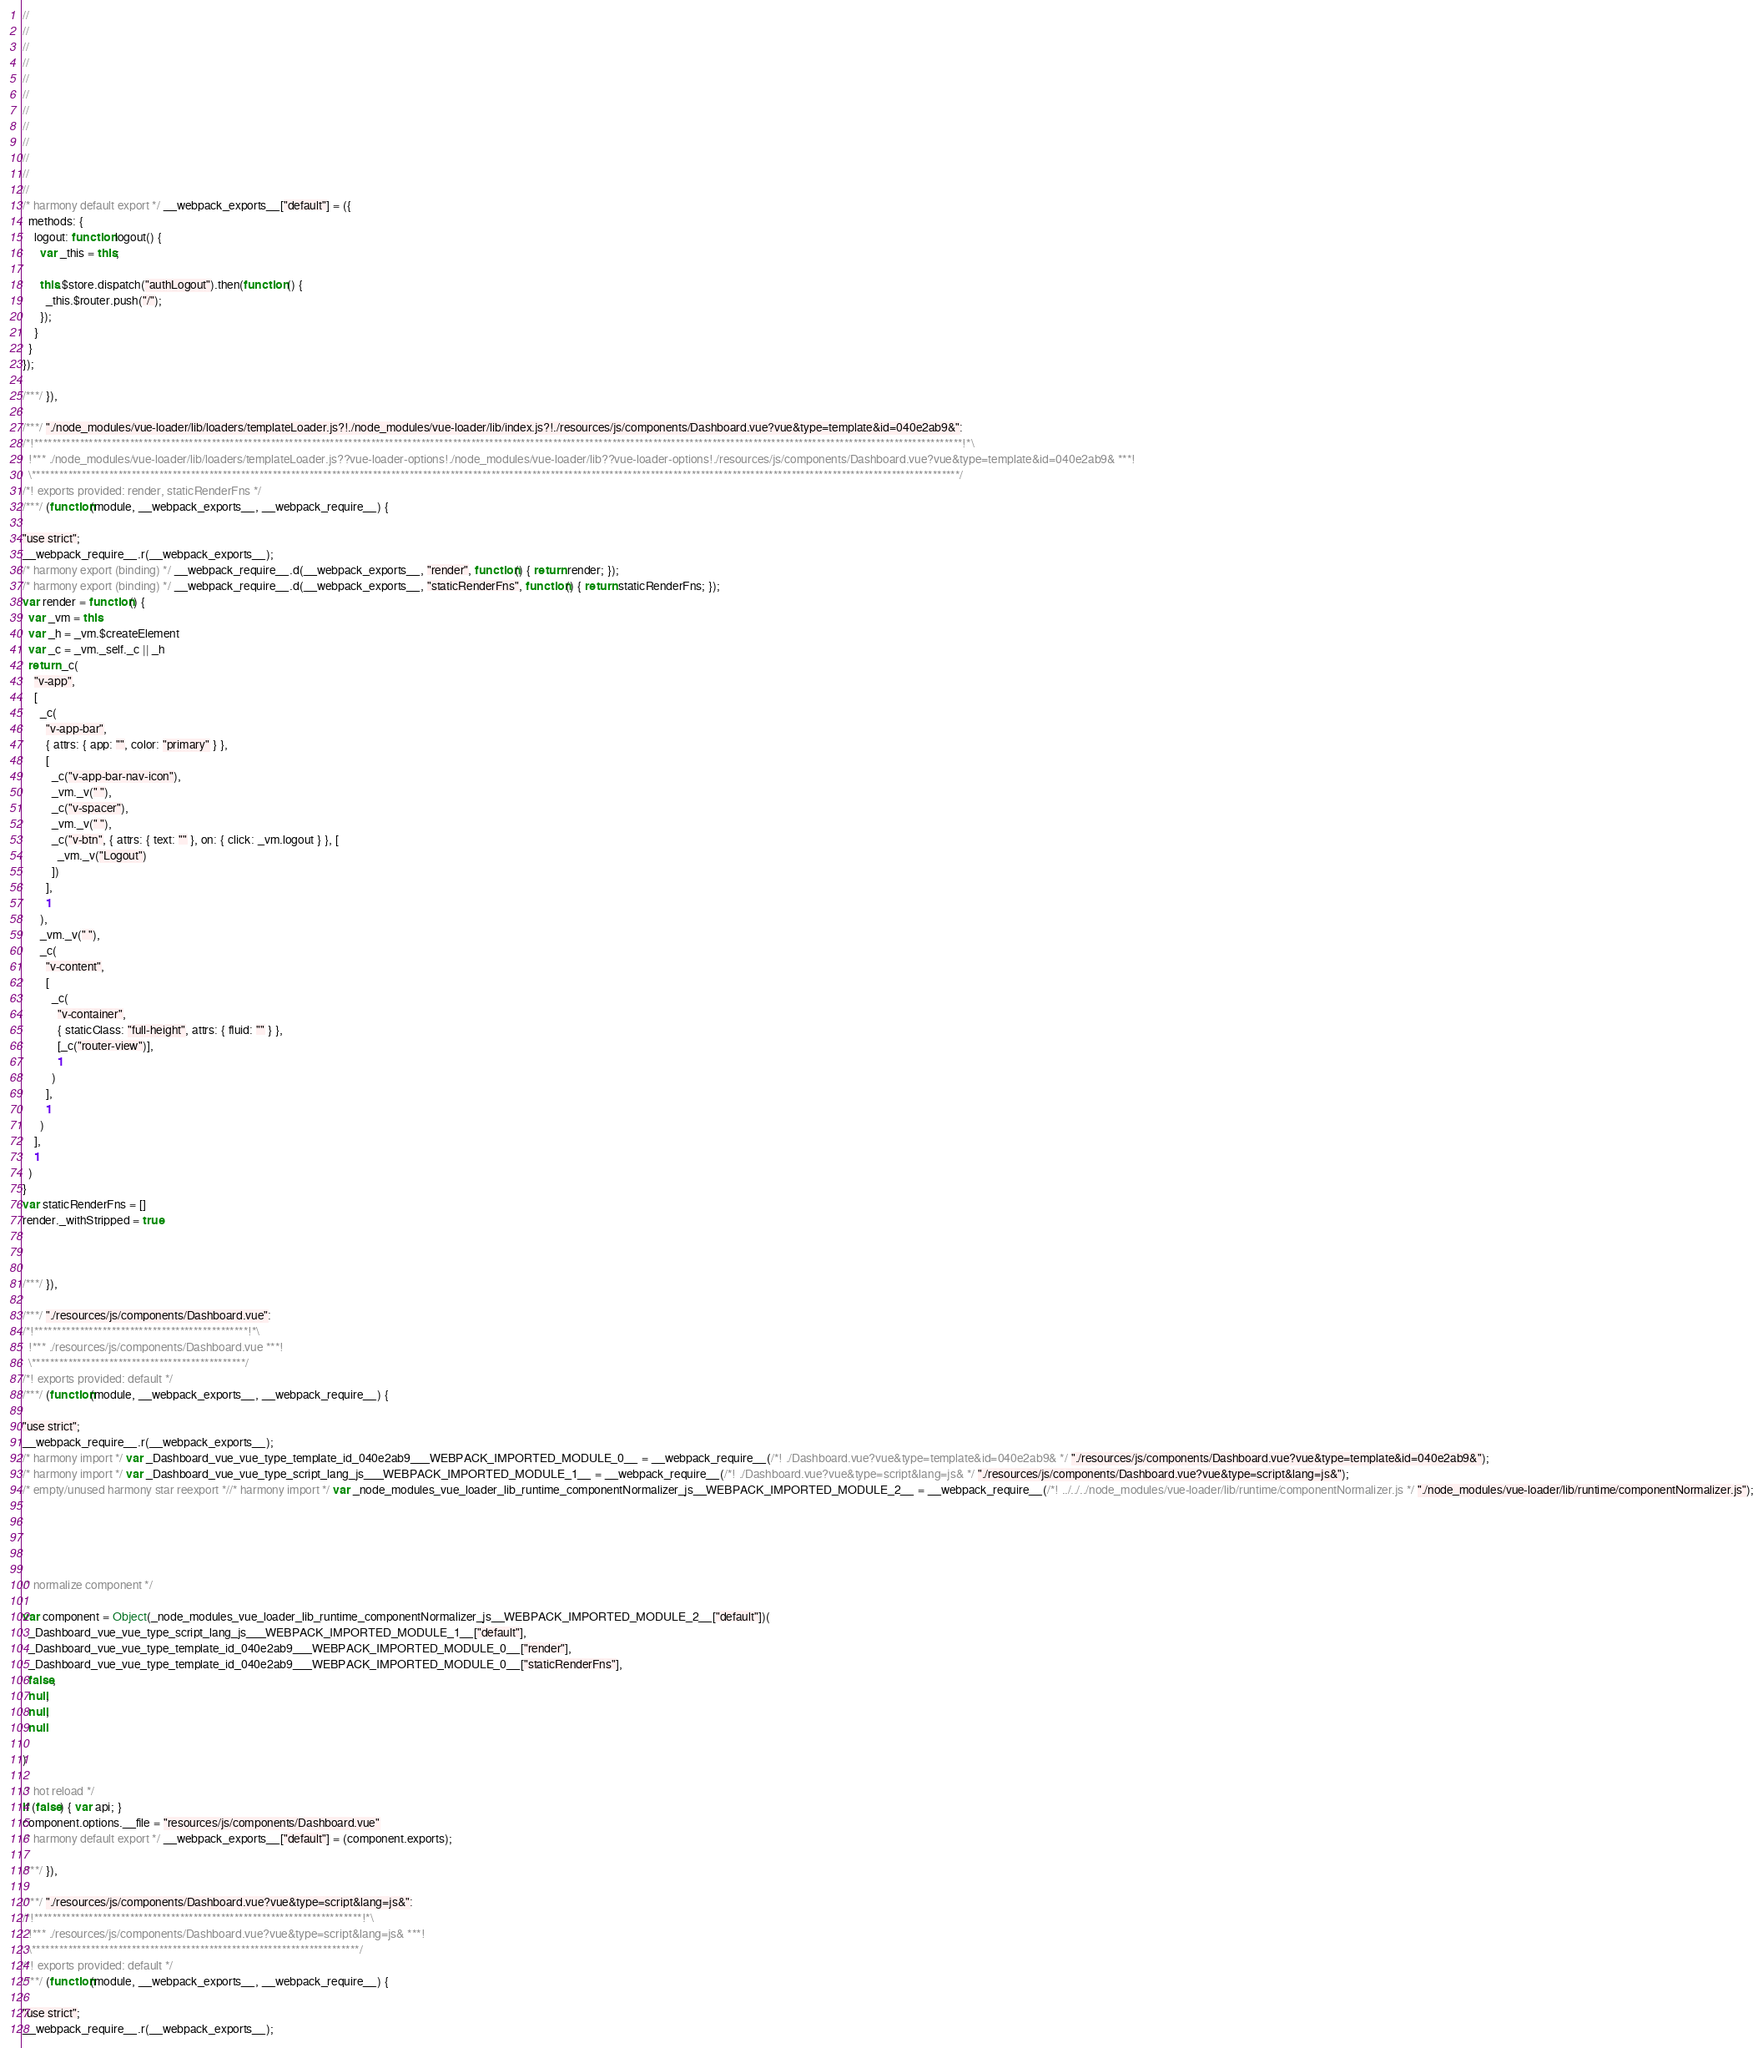Convert code to text. <code><loc_0><loc_0><loc_500><loc_500><_JavaScript_>//
//
//
//
//
//
//
//
//
//
//
//
/* harmony default export */ __webpack_exports__["default"] = ({
  methods: {
    logout: function logout() {
      var _this = this;

      this.$store.dispatch("authLogout").then(function () {
        _this.$router.push("/");
      });
    }
  }
});

/***/ }),

/***/ "./node_modules/vue-loader/lib/loaders/templateLoader.js?!./node_modules/vue-loader/lib/index.js?!./resources/js/components/Dashboard.vue?vue&type=template&id=040e2ab9&":
/*!************************************************************************************************************************************************************************************************************!*\
  !*** ./node_modules/vue-loader/lib/loaders/templateLoader.js??vue-loader-options!./node_modules/vue-loader/lib??vue-loader-options!./resources/js/components/Dashboard.vue?vue&type=template&id=040e2ab9& ***!
  \************************************************************************************************************************************************************************************************************/
/*! exports provided: render, staticRenderFns */
/***/ (function(module, __webpack_exports__, __webpack_require__) {

"use strict";
__webpack_require__.r(__webpack_exports__);
/* harmony export (binding) */ __webpack_require__.d(__webpack_exports__, "render", function() { return render; });
/* harmony export (binding) */ __webpack_require__.d(__webpack_exports__, "staticRenderFns", function() { return staticRenderFns; });
var render = function() {
  var _vm = this
  var _h = _vm.$createElement
  var _c = _vm._self._c || _h
  return _c(
    "v-app",
    [
      _c(
        "v-app-bar",
        { attrs: { app: "", color: "primary" } },
        [
          _c("v-app-bar-nav-icon"),
          _vm._v(" "),
          _c("v-spacer"),
          _vm._v(" "),
          _c("v-btn", { attrs: { text: "" }, on: { click: _vm.logout } }, [
            _vm._v("Logout")
          ])
        ],
        1
      ),
      _vm._v(" "),
      _c(
        "v-content",
        [
          _c(
            "v-container",
            { staticClass: "full-height", attrs: { fluid: "" } },
            [_c("router-view")],
            1
          )
        ],
        1
      )
    ],
    1
  )
}
var staticRenderFns = []
render._withStripped = true



/***/ }),

/***/ "./resources/js/components/Dashboard.vue":
/*!***********************************************!*\
  !*** ./resources/js/components/Dashboard.vue ***!
  \***********************************************/
/*! exports provided: default */
/***/ (function(module, __webpack_exports__, __webpack_require__) {

"use strict";
__webpack_require__.r(__webpack_exports__);
/* harmony import */ var _Dashboard_vue_vue_type_template_id_040e2ab9___WEBPACK_IMPORTED_MODULE_0__ = __webpack_require__(/*! ./Dashboard.vue?vue&type=template&id=040e2ab9& */ "./resources/js/components/Dashboard.vue?vue&type=template&id=040e2ab9&");
/* harmony import */ var _Dashboard_vue_vue_type_script_lang_js___WEBPACK_IMPORTED_MODULE_1__ = __webpack_require__(/*! ./Dashboard.vue?vue&type=script&lang=js& */ "./resources/js/components/Dashboard.vue?vue&type=script&lang=js&");
/* empty/unused harmony star reexport *//* harmony import */ var _node_modules_vue_loader_lib_runtime_componentNormalizer_js__WEBPACK_IMPORTED_MODULE_2__ = __webpack_require__(/*! ../../../node_modules/vue-loader/lib/runtime/componentNormalizer.js */ "./node_modules/vue-loader/lib/runtime/componentNormalizer.js");





/* normalize component */

var component = Object(_node_modules_vue_loader_lib_runtime_componentNormalizer_js__WEBPACK_IMPORTED_MODULE_2__["default"])(
  _Dashboard_vue_vue_type_script_lang_js___WEBPACK_IMPORTED_MODULE_1__["default"],
  _Dashboard_vue_vue_type_template_id_040e2ab9___WEBPACK_IMPORTED_MODULE_0__["render"],
  _Dashboard_vue_vue_type_template_id_040e2ab9___WEBPACK_IMPORTED_MODULE_0__["staticRenderFns"],
  false,
  null,
  null,
  null
  
)

/* hot reload */
if (false) { var api; }
component.options.__file = "resources/js/components/Dashboard.vue"
/* harmony default export */ __webpack_exports__["default"] = (component.exports);

/***/ }),

/***/ "./resources/js/components/Dashboard.vue?vue&type=script&lang=js&":
/*!************************************************************************!*\
  !*** ./resources/js/components/Dashboard.vue?vue&type=script&lang=js& ***!
  \************************************************************************/
/*! exports provided: default */
/***/ (function(module, __webpack_exports__, __webpack_require__) {

"use strict";
__webpack_require__.r(__webpack_exports__);</code> 